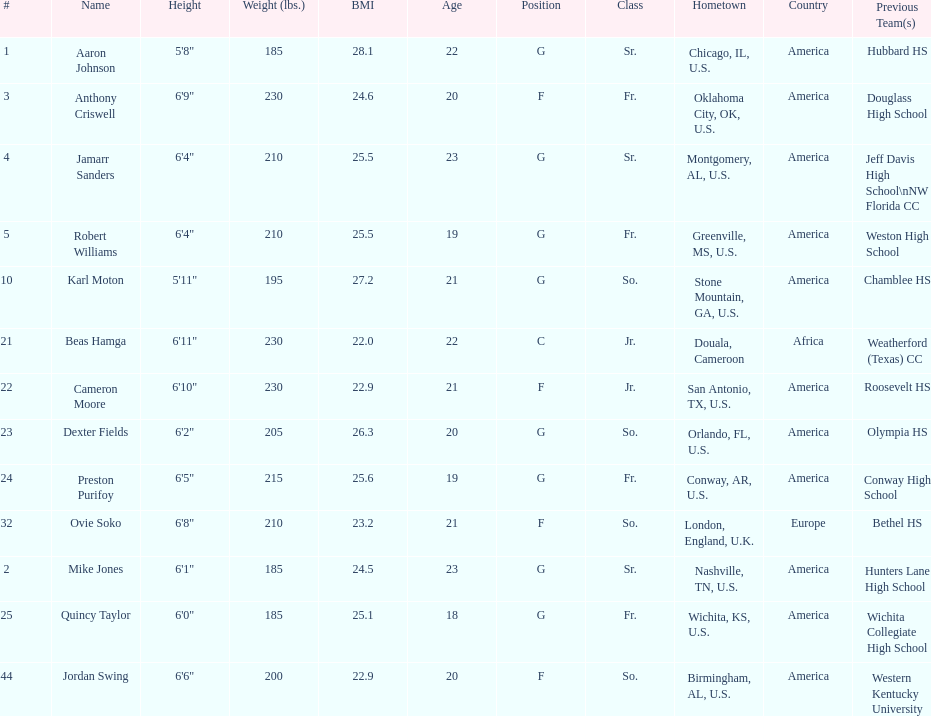Who is the tallest player on the team? Beas Hamga. 